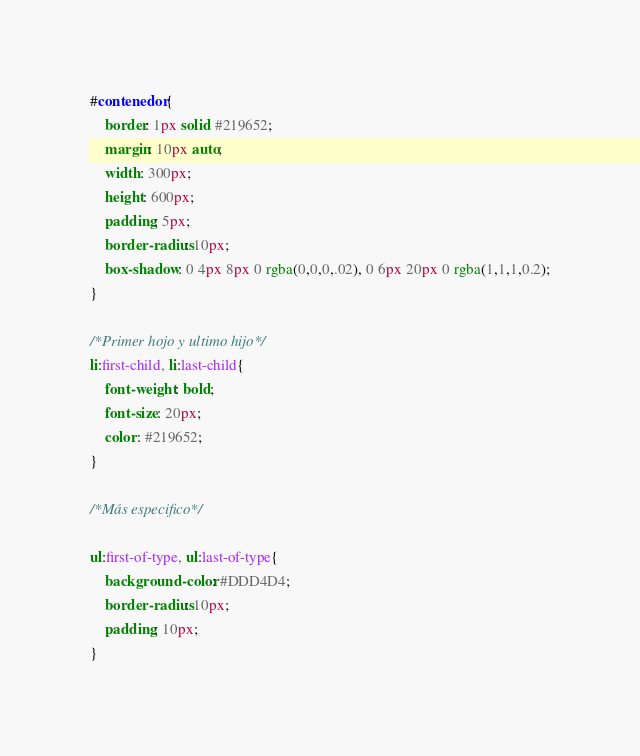<code> <loc_0><loc_0><loc_500><loc_500><_CSS_>#contenedor{
    border: 1px solid #219652;
    margin: 10px auto;
    width: 300px;
    height: 600px;
    padding: 5px;
    border-radius: 10px;
    box-shadow: 0 4px 8px 0 rgba(0,0,0,.02), 0 6px 20px 0 rgba(1,1,1,0.2);
}

/*Primer hojo y ultimo hijo*/
li:first-child, li:last-child{
    font-weight: bold;
    font-size: 20px;
    color: #219652;
}

/*Más especifico*/

ul:first-of-type, ul:last-of-type{
    background-color: #DDD4D4;
    border-radius: 10px;
    padding: 10px;
}</code> 